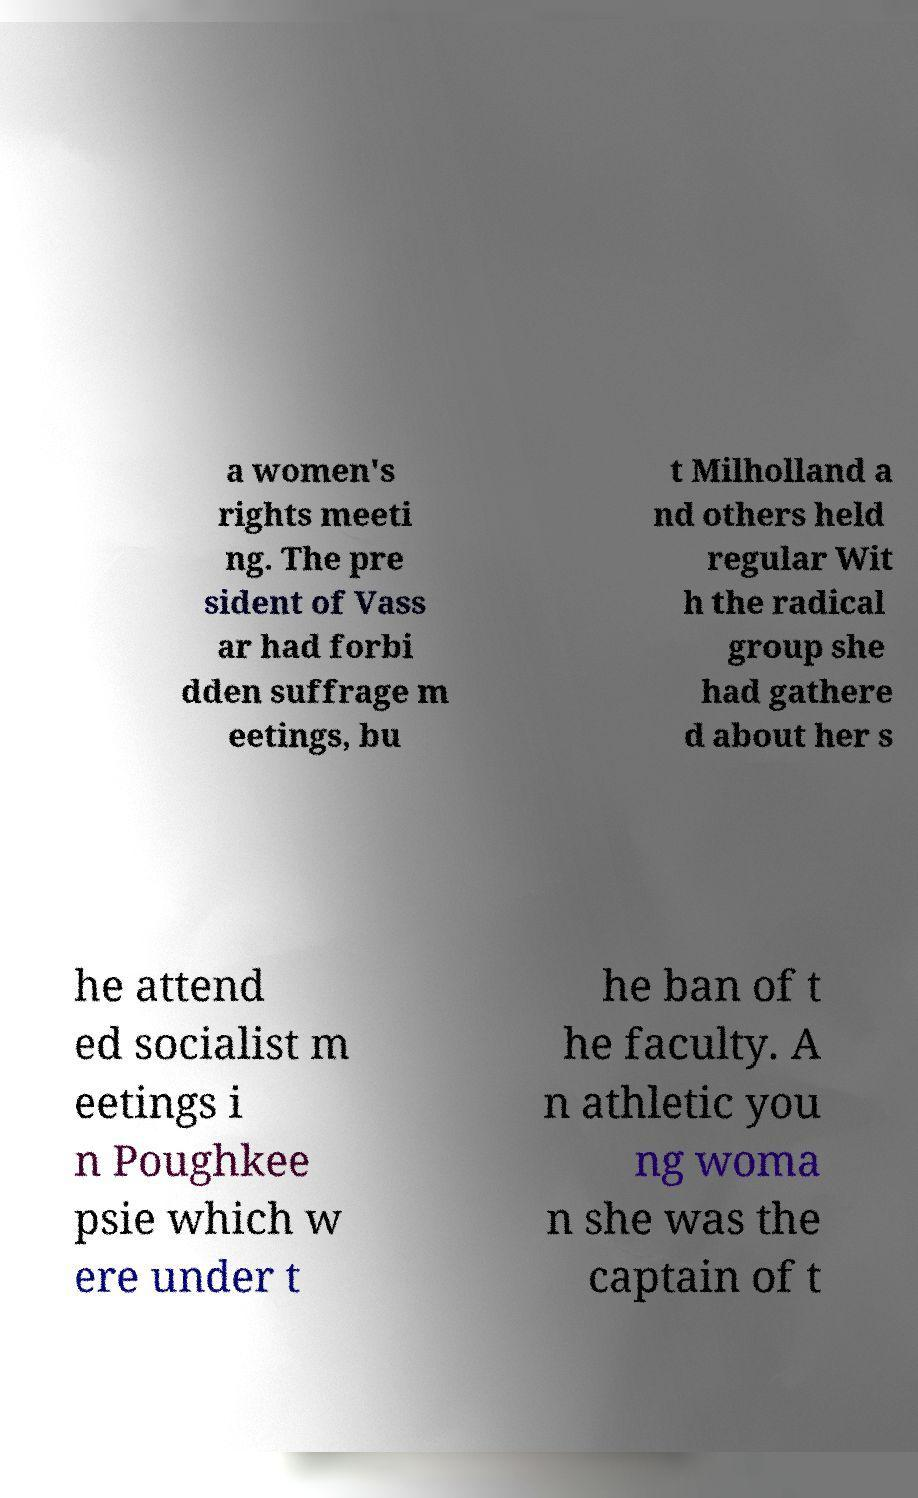I need the written content from this picture converted into text. Can you do that? a women's rights meeti ng. The pre sident of Vass ar had forbi dden suffrage m eetings, bu t Milholland a nd others held regular Wit h the radical group she had gathere d about her s he attend ed socialist m eetings i n Poughkee psie which w ere under t he ban of t he faculty. A n athletic you ng woma n she was the captain of t 